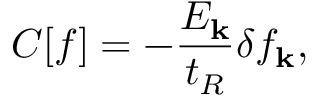Convert formula to latex. <formula><loc_0><loc_0><loc_500><loc_500>C [ f ] = - \frac { E _ { k } } { t _ { R } } \delta f _ { k } ,</formula> 